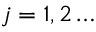<formula> <loc_0><loc_0><loc_500><loc_500>j = 1 , 2 \dots</formula> 